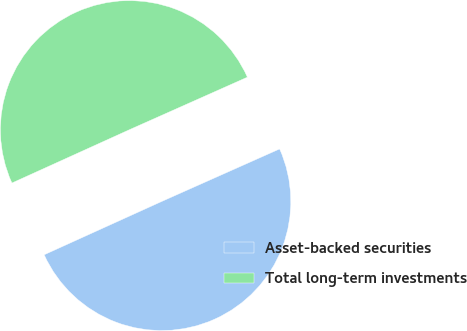Convert chart. <chart><loc_0><loc_0><loc_500><loc_500><pie_chart><fcel>Asset-backed securities<fcel>Total long-term investments<nl><fcel>49.89%<fcel>50.11%<nl></chart> 